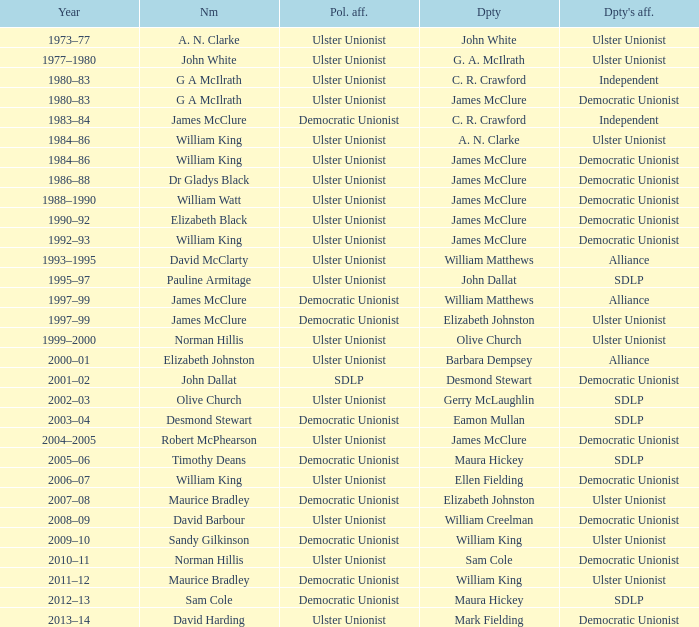What is the name of the deputy in 1992–93? James McClure. Write the full table. {'header': ['Year', 'Nm', 'Pol. aff.', 'Dpty', "Dpty's aff."], 'rows': [['1973–77', 'A. N. Clarke', 'Ulster Unionist', 'John White', 'Ulster Unionist'], ['1977–1980', 'John White', 'Ulster Unionist', 'G. A. McIlrath', 'Ulster Unionist'], ['1980–83', 'G A McIlrath', 'Ulster Unionist', 'C. R. Crawford', 'Independent'], ['1980–83', 'G A McIlrath', 'Ulster Unionist', 'James McClure', 'Democratic Unionist'], ['1983–84', 'James McClure', 'Democratic Unionist', 'C. R. Crawford', 'Independent'], ['1984–86', 'William King', 'Ulster Unionist', 'A. N. Clarke', 'Ulster Unionist'], ['1984–86', 'William King', 'Ulster Unionist', 'James McClure', 'Democratic Unionist'], ['1986–88', 'Dr Gladys Black', 'Ulster Unionist', 'James McClure', 'Democratic Unionist'], ['1988–1990', 'William Watt', 'Ulster Unionist', 'James McClure', 'Democratic Unionist'], ['1990–92', 'Elizabeth Black', 'Ulster Unionist', 'James McClure', 'Democratic Unionist'], ['1992–93', 'William King', 'Ulster Unionist', 'James McClure', 'Democratic Unionist'], ['1993–1995', 'David McClarty', 'Ulster Unionist', 'William Matthews', 'Alliance'], ['1995–97', 'Pauline Armitage', 'Ulster Unionist', 'John Dallat', 'SDLP'], ['1997–99', 'James McClure', 'Democratic Unionist', 'William Matthews', 'Alliance'], ['1997–99', 'James McClure', 'Democratic Unionist', 'Elizabeth Johnston', 'Ulster Unionist'], ['1999–2000', 'Norman Hillis', 'Ulster Unionist', 'Olive Church', 'Ulster Unionist'], ['2000–01', 'Elizabeth Johnston', 'Ulster Unionist', 'Barbara Dempsey', 'Alliance'], ['2001–02', 'John Dallat', 'SDLP', 'Desmond Stewart', 'Democratic Unionist'], ['2002–03', 'Olive Church', 'Ulster Unionist', 'Gerry McLaughlin', 'SDLP'], ['2003–04', 'Desmond Stewart', 'Democratic Unionist', 'Eamon Mullan', 'SDLP'], ['2004–2005', 'Robert McPhearson', 'Ulster Unionist', 'James McClure', 'Democratic Unionist'], ['2005–06', 'Timothy Deans', 'Democratic Unionist', 'Maura Hickey', 'SDLP'], ['2006–07', 'William King', 'Ulster Unionist', 'Ellen Fielding', 'Democratic Unionist'], ['2007–08', 'Maurice Bradley', 'Democratic Unionist', 'Elizabeth Johnston', 'Ulster Unionist'], ['2008–09', 'David Barbour', 'Ulster Unionist', 'William Creelman', 'Democratic Unionist'], ['2009–10', 'Sandy Gilkinson', 'Democratic Unionist', 'William King', 'Ulster Unionist'], ['2010–11', 'Norman Hillis', 'Ulster Unionist', 'Sam Cole', 'Democratic Unionist'], ['2011–12', 'Maurice Bradley', 'Democratic Unionist', 'William King', 'Ulster Unionist'], ['2012–13', 'Sam Cole', 'Democratic Unionist', 'Maura Hickey', 'SDLP'], ['2013–14', 'David Harding', 'Ulster Unionist', 'Mark Fielding', 'Democratic Unionist']]} 